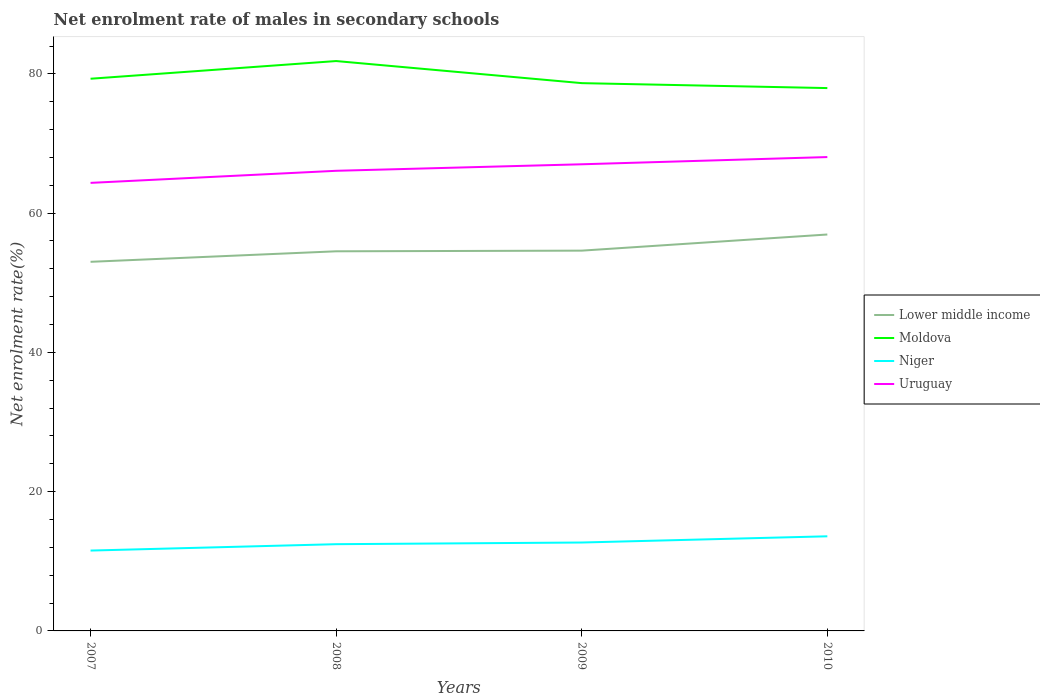Across all years, what is the maximum net enrolment rate of males in secondary schools in Moldova?
Keep it short and to the point. 77.96. What is the total net enrolment rate of males in secondary schools in Uruguay in the graph?
Your answer should be very brief. -1.97. What is the difference between the highest and the second highest net enrolment rate of males in secondary schools in Uruguay?
Provide a succinct answer. 3.71. What is the difference between the highest and the lowest net enrolment rate of males in secondary schools in Uruguay?
Keep it short and to the point. 2. How many lines are there?
Your response must be concise. 4. What is the difference between two consecutive major ticks on the Y-axis?
Your answer should be compact. 20. Does the graph contain any zero values?
Keep it short and to the point. No. Does the graph contain grids?
Offer a terse response. No. Where does the legend appear in the graph?
Your response must be concise. Center right. How many legend labels are there?
Provide a short and direct response. 4. How are the legend labels stacked?
Offer a very short reply. Vertical. What is the title of the graph?
Provide a succinct answer. Net enrolment rate of males in secondary schools. Does "Mongolia" appear as one of the legend labels in the graph?
Make the answer very short. No. What is the label or title of the X-axis?
Your response must be concise. Years. What is the label or title of the Y-axis?
Provide a succinct answer. Net enrolment rate(%). What is the Net enrolment rate(%) of Lower middle income in 2007?
Offer a terse response. 53.01. What is the Net enrolment rate(%) in Moldova in 2007?
Provide a succinct answer. 79.3. What is the Net enrolment rate(%) in Niger in 2007?
Make the answer very short. 11.54. What is the Net enrolment rate(%) of Uruguay in 2007?
Offer a very short reply. 64.35. What is the Net enrolment rate(%) in Lower middle income in 2008?
Provide a succinct answer. 54.52. What is the Net enrolment rate(%) of Moldova in 2008?
Provide a short and direct response. 81.84. What is the Net enrolment rate(%) in Niger in 2008?
Make the answer very short. 12.46. What is the Net enrolment rate(%) in Uruguay in 2008?
Provide a short and direct response. 66.08. What is the Net enrolment rate(%) in Lower middle income in 2009?
Offer a very short reply. 54.61. What is the Net enrolment rate(%) of Moldova in 2009?
Ensure brevity in your answer.  78.67. What is the Net enrolment rate(%) of Niger in 2009?
Offer a very short reply. 12.7. What is the Net enrolment rate(%) of Uruguay in 2009?
Offer a very short reply. 67.02. What is the Net enrolment rate(%) in Lower middle income in 2010?
Ensure brevity in your answer.  56.93. What is the Net enrolment rate(%) of Moldova in 2010?
Your answer should be very brief. 77.96. What is the Net enrolment rate(%) in Niger in 2010?
Your answer should be compact. 13.59. What is the Net enrolment rate(%) in Uruguay in 2010?
Ensure brevity in your answer.  68.05. Across all years, what is the maximum Net enrolment rate(%) of Lower middle income?
Give a very brief answer. 56.93. Across all years, what is the maximum Net enrolment rate(%) in Moldova?
Your answer should be very brief. 81.84. Across all years, what is the maximum Net enrolment rate(%) of Niger?
Provide a succinct answer. 13.59. Across all years, what is the maximum Net enrolment rate(%) in Uruguay?
Ensure brevity in your answer.  68.05. Across all years, what is the minimum Net enrolment rate(%) of Lower middle income?
Your response must be concise. 53.01. Across all years, what is the minimum Net enrolment rate(%) in Moldova?
Offer a terse response. 77.96. Across all years, what is the minimum Net enrolment rate(%) in Niger?
Offer a very short reply. 11.54. Across all years, what is the minimum Net enrolment rate(%) in Uruguay?
Ensure brevity in your answer.  64.35. What is the total Net enrolment rate(%) in Lower middle income in the graph?
Provide a succinct answer. 219.07. What is the total Net enrolment rate(%) in Moldova in the graph?
Keep it short and to the point. 317.77. What is the total Net enrolment rate(%) in Niger in the graph?
Your answer should be compact. 50.28. What is the total Net enrolment rate(%) of Uruguay in the graph?
Offer a very short reply. 265.49. What is the difference between the Net enrolment rate(%) in Lower middle income in 2007 and that in 2008?
Offer a terse response. -1.51. What is the difference between the Net enrolment rate(%) of Moldova in 2007 and that in 2008?
Provide a short and direct response. -2.54. What is the difference between the Net enrolment rate(%) of Niger in 2007 and that in 2008?
Make the answer very short. -0.92. What is the difference between the Net enrolment rate(%) of Uruguay in 2007 and that in 2008?
Ensure brevity in your answer.  -1.73. What is the difference between the Net enrolment rate(%) in Lower middle income in 2007 and that in 2009?
Your answer should be compact. -1.6. What is the difference between the Net enrolment rate(%) in Moldova in 2007 and that in 2009?
Your answer should be very brief. 0.63. What is the difference between the Net enrolment rate(%) of Niger in 2007 and that in 2009?
Offer a terse response. -1.15. What is the difference between the Net enrolment rate(%) of Uruguay in 2007 and that in 2009?
Provide a short and direct response. -2.67. What is the difference between the Net enrolment rate(%) in Lower middle income in 2007 and that in 2010?
Make the answer very short. -3.92. What is the difference between the Net enrolment rate(%) of Moldova in 2007 and that in 2010?
Your answer should be compact. 1.34. What is the difference between the Net enrolment rate(%) in Niger in 2007 and that in 2010?
Provide a short and direct response. -2.05. What is the difference between the Net enrolment rate(%) in Uruguay in 2007 and that in 2010?
Keep it short and to the point. -3.71. What is the difference between the Net enrolment rate(%) of Lower middle income in 2008 and that in 2009?
Provide a short and direct response. -0.09. What is the difference between the Net enrolment rate(%) of Moldova in 2008 and that in 2009?
Your answer should be very brief. 3.17. What is the difference between the Net enrolment rate(%) of Niger in 2008 and that in 2009?
Your response must be concise. -0.24. What is the difference between the Net enrolment rate(%) in Uruguay in 2008 and that in 2009?
Provide a short and direct response. -0.94. What is the difference between the Net enrolment rate(%) of Lower middle income in 2008 and that in 2010?
Your response must be concise. -2.41. What is the difference between the Net enrolment rate(%) of Moldova in 2008 and that in 2010?
Offer a very short reply. 3.88. What is the difference between the Net enrolment rate(%) of Niger in 2008 and that in 2010?
Your response must be concise. -1.13. What is the difference between the Net enrolment rate(%) in Uruguay in 2008 and that in 2010?
Offer a very short reply. -1.97. What is the difference between the Net enrolment rate(%) of Lower middle income in 2009 and that in 2010?
Give a very brief answer. -2.32. What is the difference between the Net enrolment rate(%) of Moldova in 2009 and that in 2010?
Offer a terse response. 0.71. What is the difference between the Net enrolment rate(%) of Niger in 2009 and that in 2010?
Keep it short and to the point. -0.89. What is the difference between the Net enrolment rate(%) in Uruguay in 2009 and that in 2010?
Offer a very short reply. -1.04. What is the difference between the Net enrolment rate(%) in Lower middle income in 2007 and the Net enrolment rate(%) in Moldova in 2008?
Your answer should be compact. -28.83. What is the difference between the Net enrolment rate(%) of Lower middle income in 2007 and the Net enrolment rate(%) of Niger in 2008?
Offer a terse response. 40.55. What is the difference between the Net enrolment rate(%) in Lower middle income in 2007 and the Net enrolment rate(%) in Uruguay in 2008?
Make the answer very short. -13.07. What is the difference between the Net enrolment rate(%) of Moldova in 2007 and the Net enrolment rate(%) of Niger in 2008?
Offer a very short reply. 66.84. What is the difference between the Net enrolment rate(%) of Moldova in 2007 and the Net enrolment rate(%) of Uruguay in 2008?
Your answer should be very brief. 13.22. What is the difference between the Net enrolment rate(%) in Niger in 2007 and the Net enrolment rate(%) in Uruguay in 2008?
Offer a terse response. -54.54. What is the difference between the Net enrolment rate(%) of Lower middle income in 2007 and the Net enrolment rate(%) of Moldova in 2009?
Your answer should be very brief. -25.66. What is the difference between the Net enrolment rate(%) of Lower middle income in 2007 and the Net enrolment rate(%) of Niger in 2009?
Make the answer very short. 40.31. What is the difference between the Net enrolment rate(%) in Lower middle income in 2007 and the Net enrolment rate(%) in Uruguay in 2009?
Ensure brevity in your answer.  -14.01. What is the difference between the Net enrolment rate(%) in Moldova in 2007 and the Net enrolment rate(%) in Niger in 2009?
Your answer should be compact. 66.61. What is the difference between the Net enrolment rate(%) of Moldova in 2007 and the Net enrolment rate(%) of Uruguay in 2009?
Ensure brevity in your answer.  12.28. What is the difference between the Net enrolment rate(%) in Niger in 2007 and the Net enrolment rate(%) in Uruguay in 2009?
Provide a short and direct response. -55.47. What is the difference between the Net enrolment rate(%) of Lower middle income in 2007 and the Net enrolment rate(%) of Moldova in 2010?
Provide a succinct answer. -24.95. What is the difference between the Net enrolment rate(%) of Lower middle income in 2007 and the Net enrolment rate(%) of Niger in 2010?
Keep it short and to the point. 39.42. What is the difference between the Net enrolment rate(%) in Lower middle income in 2007 and the Net enrolment rate(%) in Uruguay in 2010?
Your response must be concise. -15.04. What is the difference between the Net enrolment rate(%) in Moldova in 2007 and the Net enrolment rate(%) in Niger in 2010?
Keep it short and to the point. 65.71. What is the difference between the Net enrolment rate(%) in Moldova in 2007 and the Net enrolment rate(%) in Uruguay in 2010?
Offer a very short reply. 11.25. What is the difference between the Net enrolment rate(%) in Niger in 2007 and the Net enrolment rate(%) in Uruguay in 2010?
Your answer should be very brief. -56.51. What is the difference between the Net enrolment rate(%) of Lower middle income in 2008 and the Net enrolment rate(%) of Moldova in 2009?
Keep it short and to the point. -24.15. What is the difference between the Net enrolment rate(%) of Lower middle income in 2008 and the Net enrolment rate(%) of Niger in 2009?
Give a very brief answer. 41.82. What is the difference between the Net enrolment rate(%) in Lower middle income in 2008 and the Net enrolment rate(%) in Uruguay in 2009?
Provide a short and direct response. -12.5. What is the difference between the Net enrolment rate(%) of Moldova in 2008 and the Net enrolment rate(%) of Niger in 2009?
Your answer should be very brief. 69.14. What is the difference between the Net enrolment rate(%) in Moldova in 2008 and the Net enrolment rate(%) in Uruguay in 2009?
Your answer should be very brief. 14.82. What is the difference between the Net enrolment rate(%) of Niger in 2008 and the Net enrolment rate(%) of Uruguay in 2009?
Offer a terse response. -54.56. What is the difference between the Net enrolment rate(%) of Lower middle income in 2008 and the Net enrolment rate(%) of Moldova in 2010?
Give a very brief answer. -23.44. What is the difference between the Net enrolment rate(%) in Lower middle income in 2008 and the Net enrolment rate(%) in Niger in 2010?
Your response must be concise. 40.93. What is the difference between the Net enrolment rate(%) in Lower middle income in 2008 and the Net enrolment rate(%) in Uruguay in 2010?
Your answer should be very brief. -13.53. What is the difference between the Net enrolment rate(%) in Moldova in 2008 and the Net enrolment rate(%) in Niger in 2010?
Keep it short and to the point. 68.25. What is the difference between the Net enrolment rate(%) in Moldova in 2008 and the Net enrolment rate(%) in Uruguay in 2010?
Give a very brief answer. 13.79. What is the difference between the Net enrolment rate(%) in Niger in 2008 and the Net enrolment rate(%) in Uruguay in 2010?
Keep it short and to the point. -55.59. What is the difference between the Net enrolment rate(%) of Lower middle income in 2009 and the Net enrolment rate(%) of Moldova in 2010?
Offer a very short reply. -23.35. What is the difference between the Net enrolment rate(%) in Lower middle income in 2009 and the Net enrolment rate(%) in Niger in 2010?
Your answer should be compact. 41.02. What is the difference between the Net enrolment rate(%) of Lower middle income in 2009 and the Net enrolment rate(%) of Uruguay in 2010?
Offer a very short reply. -13.44. What is the difference between the Net enrolment rate(%) in Moldova in 2009 and the Net enrolment rate(%) in Niger in 2010?
Make the answer very short. 65.08. What is the difference between the Net enrolment rate(%) of Moldova in 2009 and the Net enrolment rate(%) of Uruguay in 2010?
Your answer should be compact. 10.62. What is the difference between the Net enrolment rate(%) in Niger in 2009 and the Net enrolment rate(%) in Uruguay in 2010?
Your answer should be very brief. -55.36. What is the average Net enrolment rate(%) of Lower middle income per year?
Make the answer very short. 54.77. What is the average Net enrolment rate(%) in Moldova per year?
Keep it short and to the point. 79.44. What is the average Net enrolment rate(%) of Niger per year?
Provide a short and direct response. 12.57. What is the average Net enrolment rate(%) in Uruguay per year?
Your response must be concise. 66.37. In the year 2007, what is the difference between the Net enrolment rate(%) in Lower middle income and Net enrolment rate(%) in Moldova?
Your answer should be compact. -26.29. In the year 2007, what is the difference between the Net enrolment rate(%) of Lower middle income and Net enrolment rate(%) of Niger?
Provide a short and direct response. 41.47. In the year 2007, what is the difference between the Net enrolment rate(%) in Lower middle income and Net enrolment rate(%) in Uruguay?
Your response must be concise. -11.34. In the year 2007, what is the difference between the Net enrolment rate(%) of Moldova and Net enrolment rate(%) of Niger?
Your answer should be very brief. 67.76. In the year 2007, what is the difference between the Net enrolment rate(%) of Moldova and Net enrolment rate(%) of Uruguay?
Provide a succinct answer. 14.96. In the year 2007, what is the difference between the Net enrolment rate(%) of Niger and Net enrolment rate(%) of Uruguay?
Provide a succinct answer. -52.8. In the year 2008, what is the difference between the Net enrolment rate(%) of Lower middle income and Net enrolment rate(%) of Moldova?
Ensure brevity in your answer.  -27.32. In the year 2008, what is the difference between the Net enrolment rate(%) of Lower middle income and Net enrolment rate(%) of Niger?
Keep it short and to the point. 42.06. In the year 2008, what is the difference between the Net enrolment rate(%) of Lower middle income and Net enrolment rate(%) of Uruguay?
Your answer should be compact. -11.56. In the year 2008, what is the difference between the Net enrolment rate(%) of Moldova and Net enrolment rate(%) of Niger?
Make the answer very short. 69.38. In the year 2008, what is the difference between the Net enrolment rate(%) in Moldova and Net enrolment rate(%) in Uruguay?
Provide a succinct answer. 15.76. In the year 2008, what is the difference between the Net enrolment rate(%) of Niger and Net enrolment rate(%) of Uruguay?
Give a very brief answer. -53.62. In the year 2009, what is the difference between the Net enrolment rate(%) of Lower middle income and Net enrolment rate(%) of Moldova?
Offer a very short reply. -24.06. In the year 2009, what is the difference between the Net enrolment rate(%) in Lower middle income and Net enrolment rate(%) in Niger?
Offer a very short reply. 41.92. In the year 2009, what is the difference between the Net enrolment rate(%) in Lower middle income and Net enrolment rate(%) in Uruguay?
Your response must be concise. -12.4. In the year 2009, what is the difference between the Net enrolment rate(%) of Moldova and Net enrolment rate(%) of Niger?
Provide a short and direct response. 65.97. In the year 2009, what is the difference between the Net enrolment rate(%) in Moldova and Net enrolment rate(%) in Uruguay?
Give a very brief answer. 11.65. In the year 2009, what is the difference between the Net enrolment rate(%) in Niger and Net enrolment rate(%) in Uruguay?
Offer a terse response. -54.32. In the year 2010, what is the difference between the Net enrolment rate(%) in Lower middle income and Net enrolment rate(%) in Moldova?
Provide a succinct answer. -21.03. In the year 2010, what is the difference between the Net enrolment rate(%) in Lower middle income and Net enrolment rate(%) in Niger?
Offer a very short reply. 43.34. In the year 2010, what is the difference between the Net enrolment rate(%) in Lower middle income and Net enrolment rate(%) in Uruguay?
Provide a succinct answer. -11.12. In the year 2010, what is the difference between the Net enrolment rate(%) of Moldova and Net enrolment rate(%) of Niger?
Your answer should be very brief. 64.37. In the year 2010, what is the difference between the Net enrolment rate(%) of Moldova and Net enrolment rate(%) of Uruguay?
Provide a short and direct response. 9.91. In the year 2010, what is the difference between the Net enrolment rate(%) in Niger and Net enrolment rate(%) in Uruguay?
Offer a terse response. -54.46. What is the ratio of the Net enrolment rate(%) of Lower middle income in 2007 to that in 2008?
Your response must be concise. 0.97. What is the ratio of the Net enrolment rate(%) of Niger in 2007 to that in 2008?
Provide a short and direct response. 0.93. What is the ratio of the Net enrolment rate(%) in Uruguay in 2007 to that in 2008?
Keep it short and to the point. 0.97. What is the ratio of the Net enrolment rate(%) in Lower middle income in 2007 to that in 2009?
Your response must be concise. 0.97. What is the ratio of the Net enrolment rate(%) in Niger in 2007 to that in 2009?
Your answer should be compact. 0.91. What is the ratio of the Net enrolment rate(%) in Uruguay in 2007 to that in 2009?
Offer a terse response. 0.96. What is the ratio of the Net enrolment rate(%) in Lower middle income in 2007 to that in 2010?
Keep it short and to the point. 0.93. What is the ratio of the Net enrolment rate(%) of Moldova in 2007 to that in 2010?
Offer a very short reply. 1.02. What is the ratio of the Net enrolment rate(%) in Niger in 2007 to that in 2010?
Provide a succinct answer. 0.85. What is the ratio of the Net enrolment rate(%) of Uruguay in 2007 to that in 2010?
Provide a succinct answer. 0.95. What is the ratio of the Net enrolment rate(%) of Lower middle income in 2008 to that in 2009?
Your answer should be very brief. 1. What is the ratio of the Net enrolment rate(%) of Moldova in 2008 to that in 2009?
Offer a very short reply. 1.04. What is the ratio of the Net enrolment rate(%) in Niger in 2008 to that in 2009?
Offer a very short reply. 0.98. What is the ratio of the Net enrolment rate(%) of Uruguay in 2008 to that in 2009?
Your answer should be compact. 0.99. What is the ratio of the Net enrolment rate(%) of Lower middle income in 2008 to that in 2010?
Offer a very short reply. 0.96. What is the ratio of the Net enrolment rate(%) in Moldova in 2008 to that in 2010?
Offer a terse response. 1.05. What is the ratio of the Net enrolment rate(%) in Lower middle income in 2009 to that in 2010?
Provide a succinct answer. 0.96. What is the ratio of the Net enrolment rate(%) in Moldova in 2009 to that in 2010?
Your response must be concise. 1.01. What is the ratio of the Net enrolment rate(%) in Niger in 2009 to that in 2010?
Your response must be concise. 0.93. What is the ratio of the Net enrolment rate(%) in Uruguay in 2009 to that in 2010?
Offer a very short reply. 0.98. What is the difference between the highest and the second highest Net enrolment rate(%) of Lower middle income?
Give a very brief answer. 2.32. What is the difference between the highest and the second highest Net enrolment rate(%) in Moldova?
Give a very brief answer. 2.54. What is the difference between the highest and the second highest Net enrolment rate(%) in Niger?
Offer a terse response. 0.89. What is the difference between the highest and the second highest Net enrolment rate(%) in Uruguay?
Make the answer very short. 1.04. What is the difference between the highest and the lowest Net enrolment rate(%) in Lower middle income?
Offer a terse response. 3.92. What is the difference between the highest and the lowest Net enrolment rate(%) of Moldova?
Ensure brevity in your answer.  3.88. What is the difference between the highest and the lowest Net enrolment rate(%) in Niger?
Your answer should be very brief. 2.05. What is the difference between the highest and the lowest Net enrolment rate(%) in Uruguay?
Make the answer very short. 3.71. 